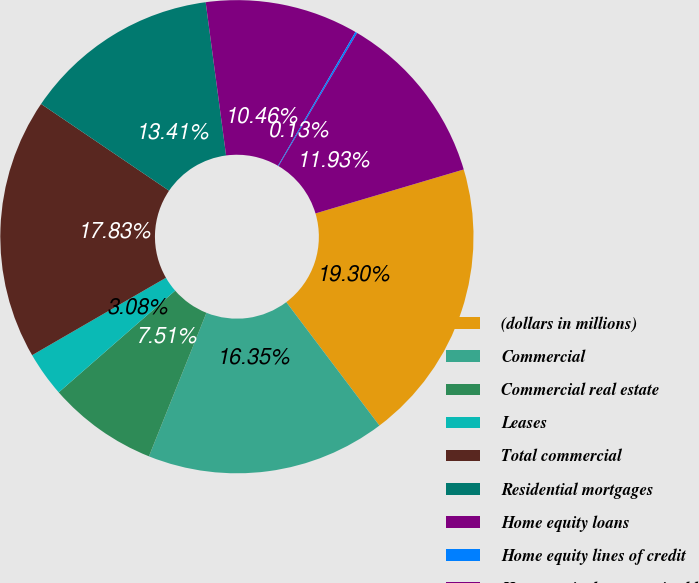Convert chart to OTSL. <chart><loc_0><loc_0><loc_500><loc_500><pie_chart><fcel>(dollars in millions)<fcel>Commercial<fcel>Commercial real estate<fcel>Leases<fcel>Total commercial<fcel>Residential mortgages<fcel>Home equity loans<fcel>Home equity lines of credit<fcel>Home equity loans serviced by<nl><fcel>19.3%<fcel>16.35%<fcel>7.51%<fcel>3.08%<fcel>17.83%<fcel>13.41%<fcel>10.46%<fcel>0.13%<fcel>11.93%<nl></chart> 